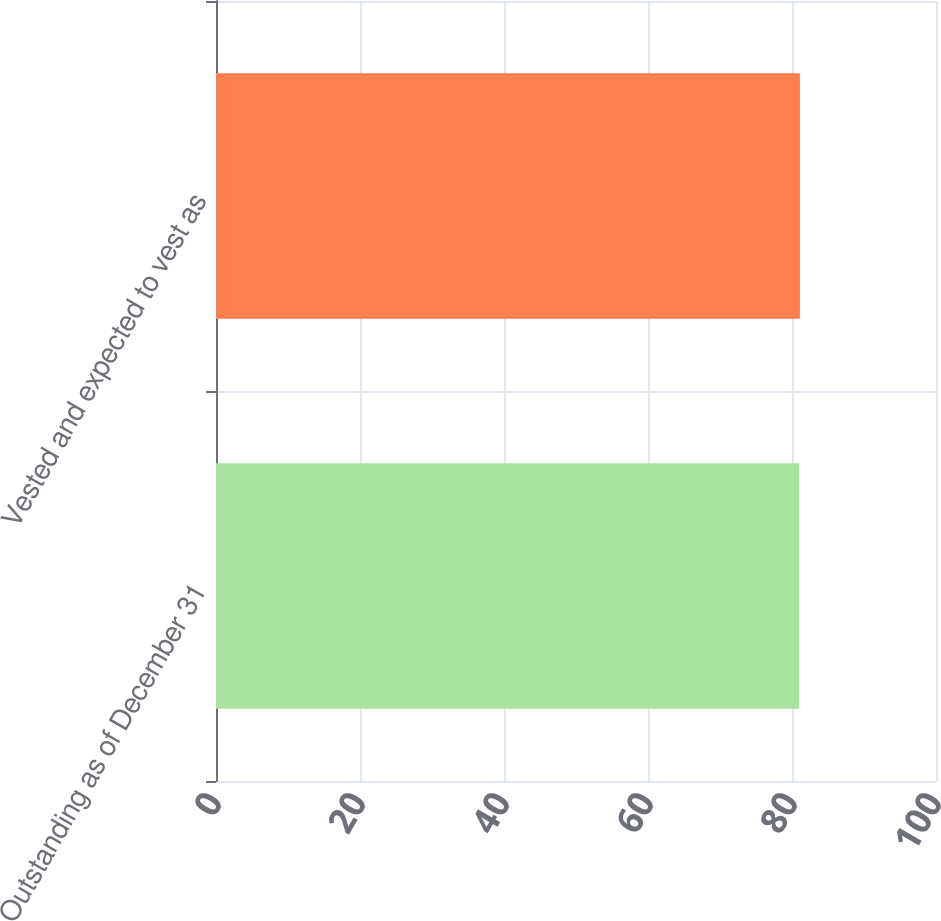Convert chart. <chart><loc_0><loc_0><loc_500><loc_500><bar_chart><fcel>Outstanding as of December 31<fcel>Vested and expected to vest as<nl><fcel>81<fcel>81.1<nl></chart> 